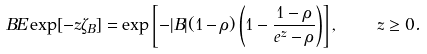Convert formula to latex. <formula><loc_0><loc_0><loc_500><loc_500>\ B E \exp [ - z \zeta _ { B } ] = \exp \left [ - | B | ( 1 - \rho ) \left ( 1 - \frac { 1 - \rho } { e ^ { z } - \rho } \right ) \right ] , \quad z \geq 0 .</formula> 